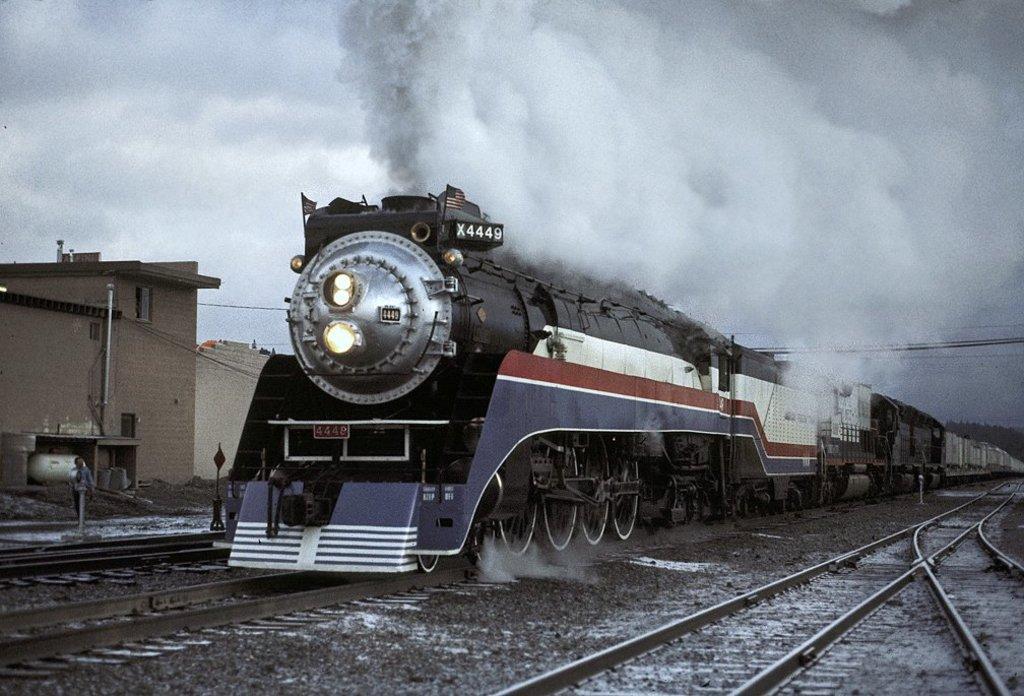Please provide a concise description of this image. In this picture I can see the passenger train on the railway track. At the top I can see the smoke which is coming from the train's engine. On the left I can see the shed and building. At the bottom I can see small stones. In the background I can see some trees. In the top left I can see the sky and clouds. 